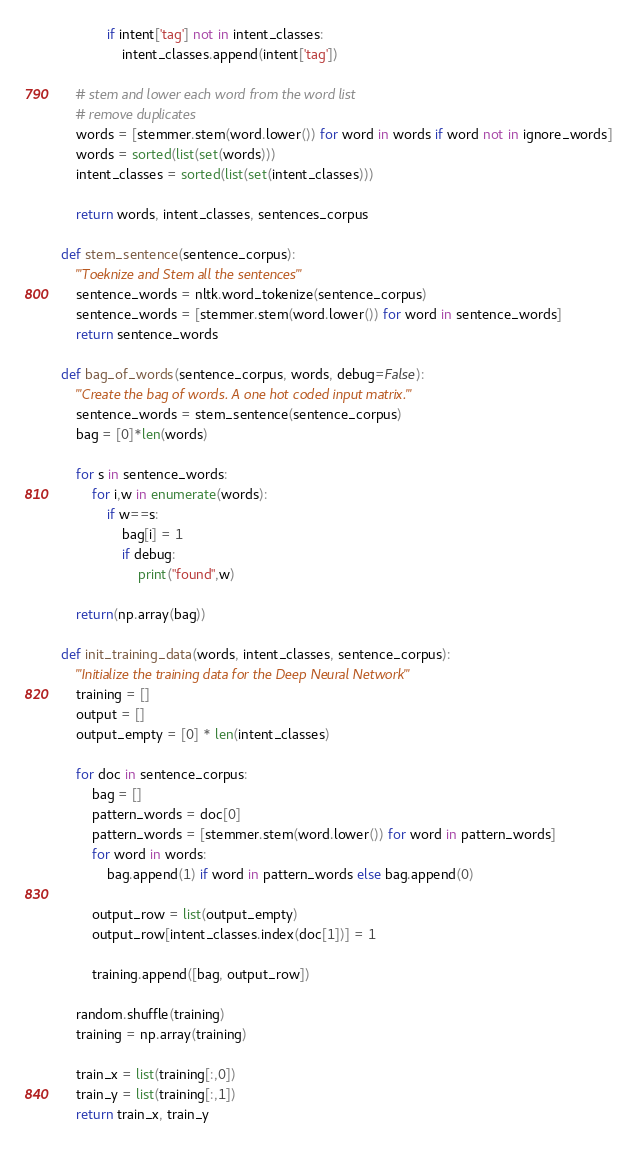Convert code to text. <code><loc_0><loc_0><loc_500><loc_500><_Python_>            if intent['tag'] not in intent_classes:
                intent_classes.append(intent['tag'])

    # stem and lower each word from the word list 
    # remove duplicates
    words = [stemmer.stem(word.lower()) for word in words if word not in ignore_words]
    words = sorted(list(set(words)))
    intent_classes = sorted(list(set(intent_classes)))

    return words, intent_classes, sentences_corpus

def stem_sentence(sentence_corpus):
    '''Toeknize and Stem all the sentences'''
    sentence_words = nltk.word_tokenize(sentence_corpus)
    sentence_words = [stemmer.stem(word.lower()) for word in sentence_words]
    return sentence_words

def bag_of_words(sentence_corpus, words, debug=False):
    '''Create the bag of words. A one hot coded input matrix.'''
    sentence_words = stem_sentence(sentence_corpus)
    bag = [0]*len(words)

    for s in sentence_words:
        for i,w in enumerate(words):
            if w==s:
                bag[i] = 1
                if debug:
                    print("found",w)

    return(np.array(bag))

def init_training_data(words, intent_classes, sentence_corpus):
    '''Initialize the training data for the Deep Neural Network'''
    training = []
    output = []
    output_empty = [0] * len(intent_classes)

    for doc in sentence_corpus:
        bag = []
        pattern_words = doc[0]
        pattern_words = [stemmer.stem(word.lower()) for word in pattern_words]
        for word in words:
            bag.append(1) if word in pattern_words else bag.append(0)

        output_row = list(output_empty)
        output_row[intent_classes.index(doc[1])] = 1
        
        training.append([bag, output_row])

    random.shuffle(training)
    training = np.array(training)

    train_x = list(training[:,0])
    train_y = list(training[:,1])
    return train_x, train_y
</code> 